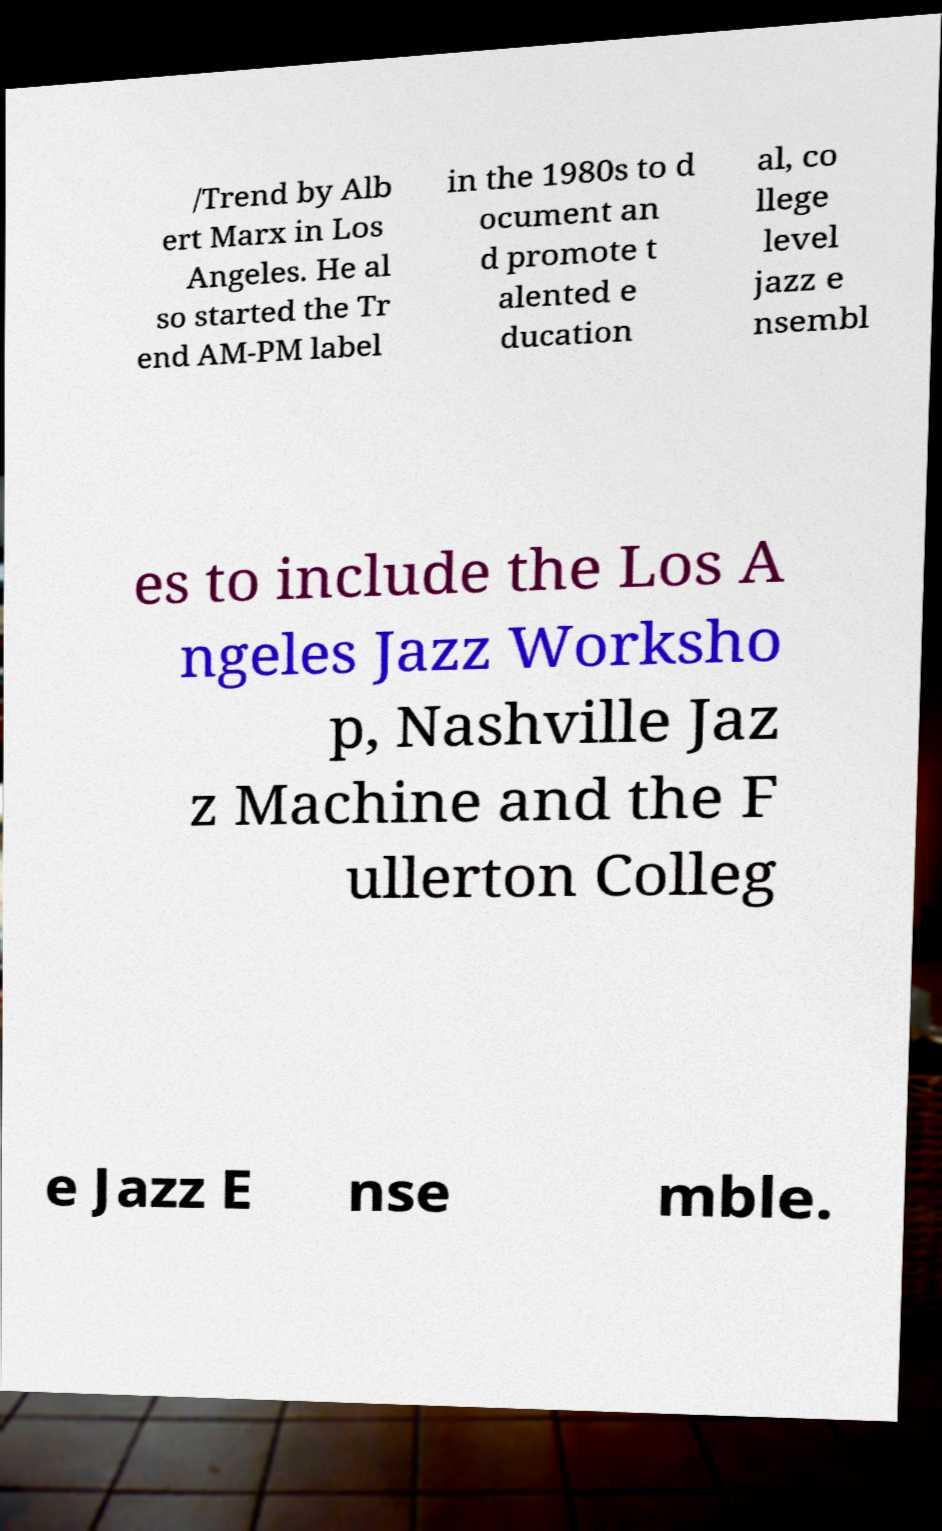What messages or text are displayed in this image? I need them in a readable, typed format. /Trend by Alb ert Marx in Los Angeles. He al so started the Tr end AM-PM label in the 1980s to d ocument an d promote t alented e ducation al, co llege level jazz e nsembl es to include the Los A ngeles Jazz Worksho p, Nashville Jaz z Machine and the F ullerton Colleg e Jazz E nse mble. 